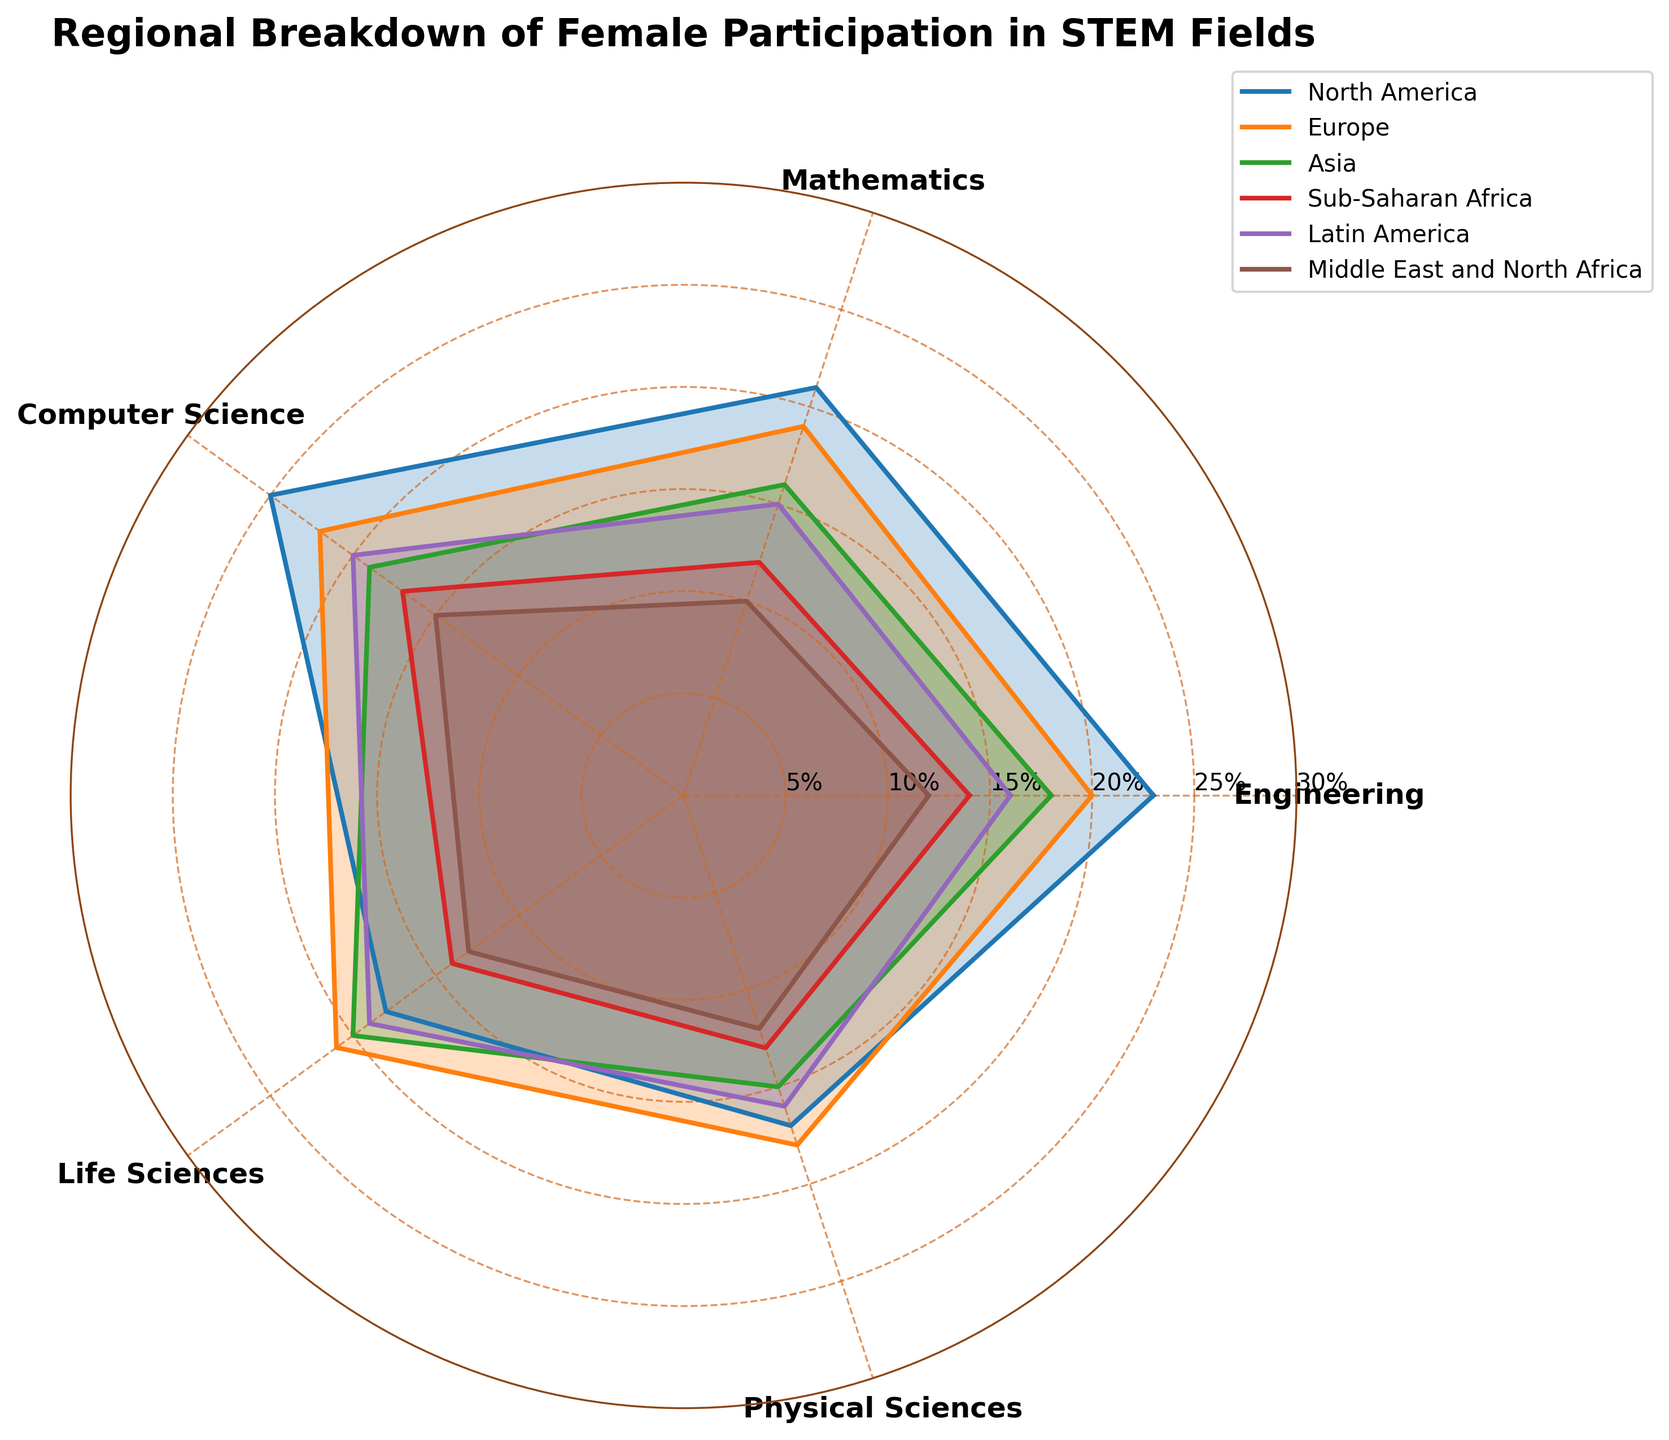What is the title of the polar chart? The title is typically found at the top of the chart and provides a concise description of the visualized data.
Answer: Regional Breakdown of Female Participation in STEM Fields Which region shows the highest female participation in Computer Science? Look for the segment labeled 'Computer Science' and find the region with the longest line extending from the center. North America exhibits the highest value for this category.
Answer: North America For which field does Sub-Saharan Africa have the lowest female participation? Identify the value points for Sub-Saharan Africa across all fields and compare. The lowest value is found for the 'Mathematics' category.
Answer: Mathematics Compare the female participation in Engineering for Asia and Europe. Which region has a higher percentage? Locate the 'Engineering' label, and compare the relative lengths of the lines representing Asia and Europe. Europe has a higher percentage.
Answer: Europe What is the average female participation in Life Sciences across all regions? Find the 'Life Sciences' values for all regions: 18, 21, 20, 14, 19, 13. Calculate the average: (18+21+20+14+19+13)/6 = 105/6 = 17.5.
Answer: 17.5% Rank the regions in descending order of female participation in Physical Sciences. Identify the values for 'Physical Sciences' for all regions and sort them: North America (17), Europe (18), Asia (15), Sub-Saharan Africa (13), Latin America (16), Middle East and North Africa (12). The sorted order is Europe, Latin America, North America, Asia, Sub-Saharan Africa, Middle East and North Africa.
Answer: Europe, Latin America, North America, Asia, Sub-Saharan Africa, Middle East and North Africa Do any two fields have equal female participation rates in North America? Identify the value points for North America: Engineering (23), Mathematics (21), Computer Science (25), Life Sciences (18), Physical Sciences (17). None of these values are equal.
Answer: No Which field has the smallest range of female participation across all regions? Calculate the range for each field by finding the difference between the highest and lowest values. Engineering (23-12=11), Mathematics (21-10=11), Computer Science (25-15=10), Life Sciences (21-13=8), Physical Sciences (18-12=6). 'Physical Sciences' has the smallest range.
Answer: Physical Sciences Is the female participation in Computer Science higher in Latin America than in Europe? Compare the values for 'Computer Science' in Latin America (20) and Europe (22). Europe's value is higher.
Answer: No What is the most balanced region in terms of female participation in all STEM fields? Balance can be determined by looking at the dispersion of values around the average. Europe has close values: Engineering (20), Mathematics (19), Computer Science (22), Life Sciences (21), Physical Sciences (18). The values are quite similar, indicating Europe is the most balanced.
Answer: Europe 